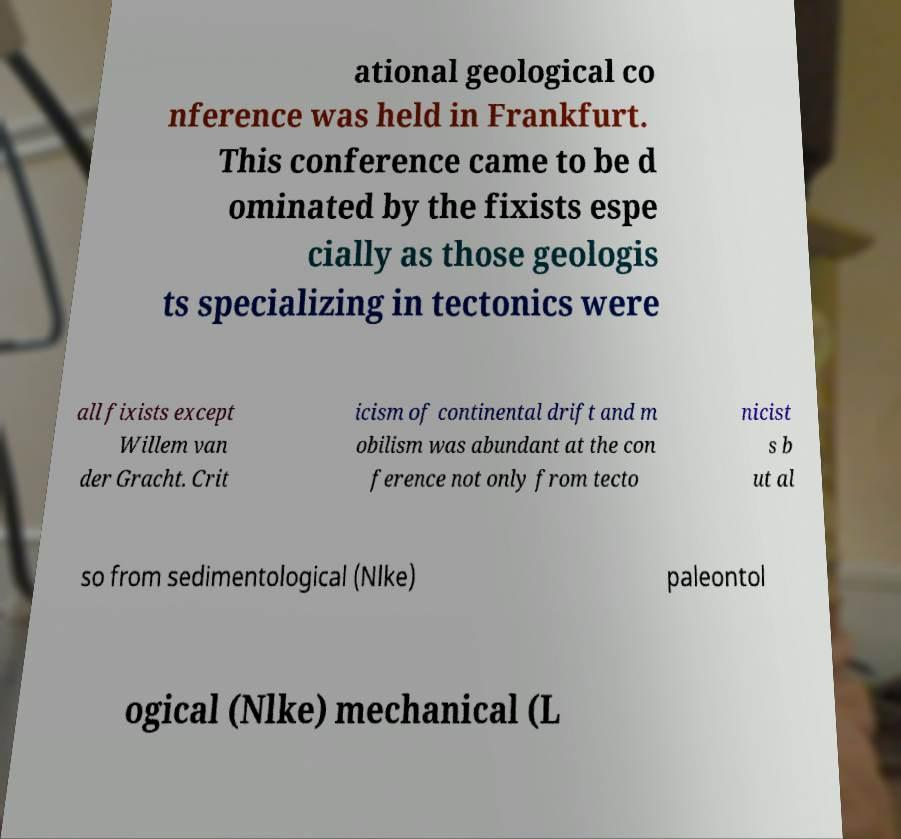There's text embedded in this image that I need extracted. Can you transcribe it verbatim? ational geological co nference was held in Frankfurt. This conference came to be d ominated by the fixists espe cially as those geologis ts specializing in tectonics were all fixists except Willem van der Gracht. Crit icism of continental drift and m obilism was abundant at the con ference not only from tecto nicist s b ut al so from sedimentological (Nlke) paleontol ogical (Nlke) mechanical (L 